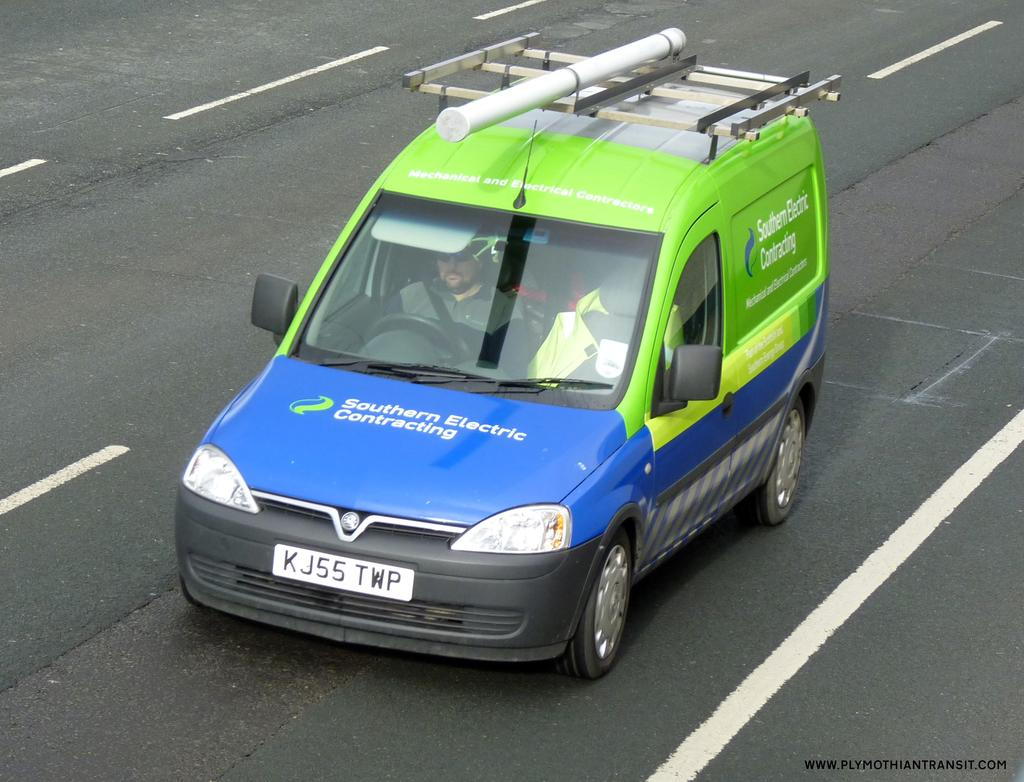What is on the road in the image? There is a vehicle on the road in the image. Who is inside the vehicle? There is a man inside the vehicle. Is there any text visible in the image? Yes, there is text visible in the bottom right corner of the image. What type of vessel is being used by the man to eat his meal in the image? There is no vessel or meal present in the image; it only shows a vehicle on the road with a man inside. 